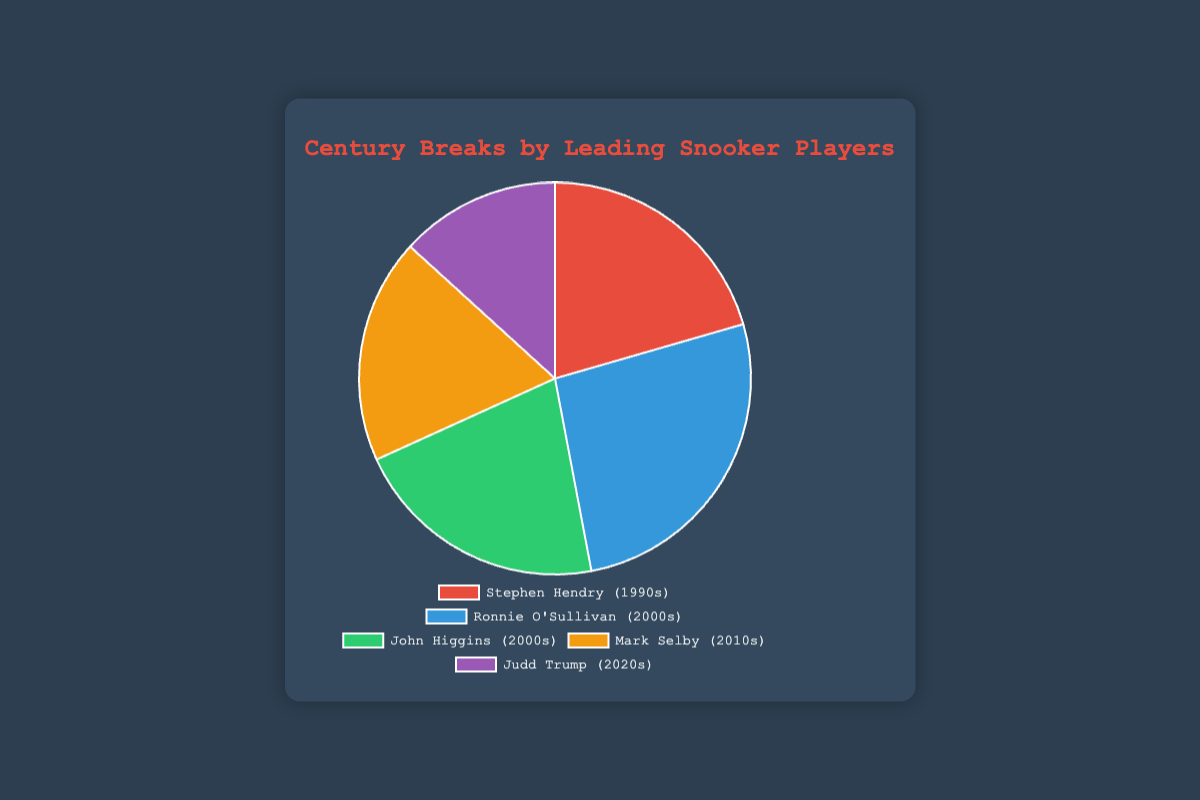Which player has the highest number of century breaks? The player with the highest number of century breaks has the largest segment in the pie chart. Ronnie O'Sullivan's segment is the largest.
Answer: Ronnie O'Sullivan How many more century breaks does Ronnie O'Sullivan have compared to Stephen Hendry? Ronnie O'Sullivan has 1000 century breaks and Stephen Hendry has 775 century breaks. The difference is calculated as 1000 - 775.
Answer: 225 What is the total number of century breaks achieved by all players combined? Adding the century breaks of each player: 775 (Stephen Hendry) + 1000 (Ronnie O'Sullivan) + 800 (John Higgins) + 700 (Mark Selby) + 500 (Judd Trump). The sum is 775 + 1000 + 800 + 700 + 500.
Answer: 3775 Which decade is represented by the player with the second highest number of century breaks? The second largest segment represents John Higgins, who has 800 century breaks, and his segment of the pie chart is labeled "2000s".
Answer: 2000s Between Mark Selby and Judd Trump, who has more century breaks and by how many? Mark Selby has 700 century breaks and Judd Trump has 500 century breaks. The difference is calculated as 700 - 500.
Answer: Mark Selby, 200 What's the average number of century breaks for the players from the 2000s? Two players (Ronnie O'Sullivan and John Higgins) represent the 2000s with 1000 and 800 century breaks respectively. The average is calculated as (1000 + 800)/2.
Answer: 900 What is the percentage of total century breaks achieved by John Higgins? John Higgins has 800 century breaks out of a total of 3775. The percentage is calculated as (800 / 3775) * 100.
Answer: Approximately 21.2% Who has more century breaks, Stephen Hendry or Mark Selby? Comparing the segments for Stephen Hendry and Mark Selby, Stephen Hendry has 775 century breaks and Mark Selby has 700 century breaks.
Answer: Stephen Hendry Arrange the players in ascending order of their century breaks. Listing the players based on their century breaks in ascending order: Judd Trump (500), Mark Selby (700), Stephen Hendry (775), John Higgins (800), Ronnie O'Sullivan (1000).
Answer: Judd Trump, Mark Selby, Stephen Hendry, John Higgins, Ronnie O'Sullivan What is the difference in century breaks between the player with the highest and lowest number? Ronnie O'Sullivan has the highest number of century breaks (1000) and Judd Trump has the lowest (500). The difference is 1000 - 500.
Answer: 500 